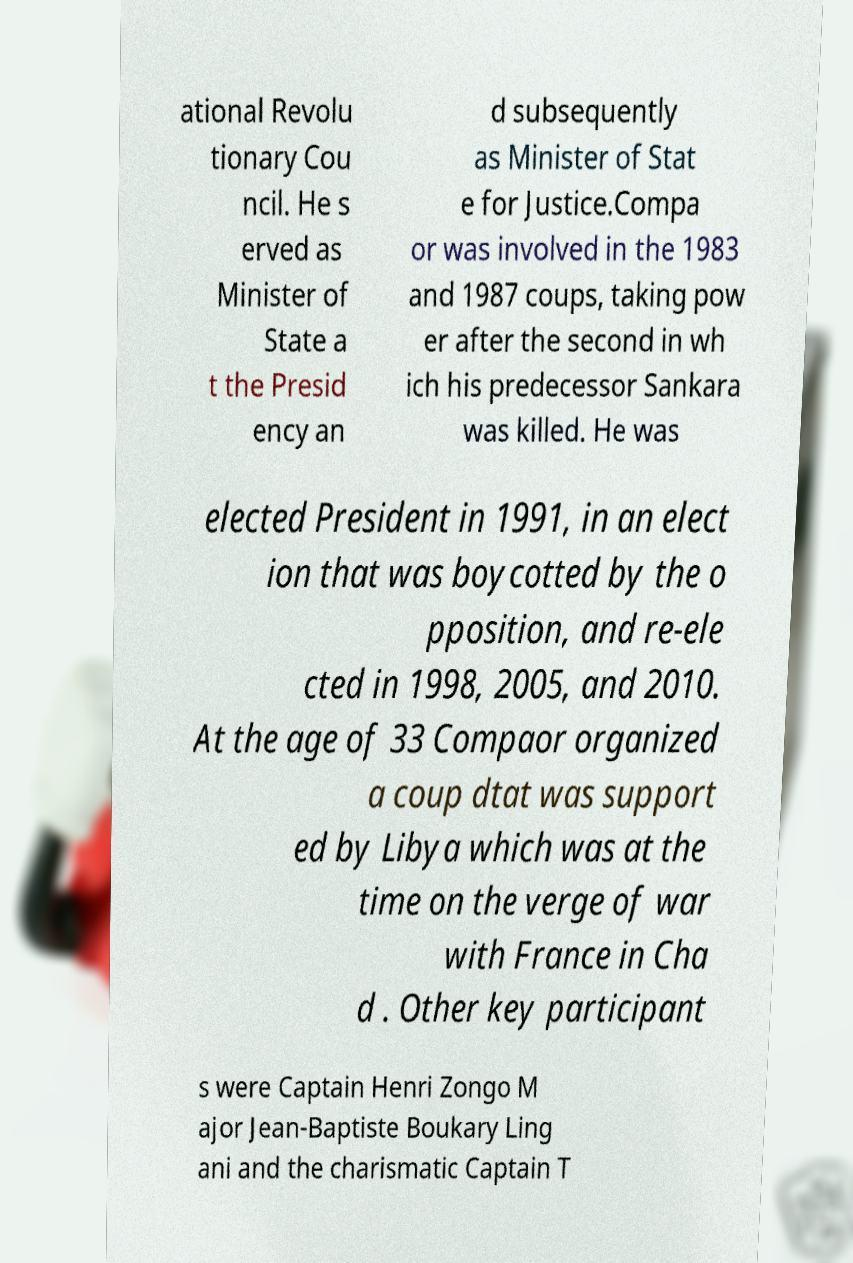What messages or text are displayed in this image? I need them in a readable, typed format. ational Revolu tionary Cou ncil. He s erved as Minister of State a t the Presid ency an d subsequently as Minister of Stat e for Justice.Compa or was involved in the 1983 and 1987 coups, taking pow er after the second in wh ich his predecessor Sankara was killed. He was elected President in 1991, in an elect ion that was boycotted by the o pposition, and re-ele cted in 1998, 2005, and 2010. At the age of 33 Compaor organized a coup dtat was support ed by Libya which was at the time on the verge of war with France in Cha d . Other key participant s were Captain Henri Zongo M ajor Jean-Baptiste Boukary Ling ani and the charismatic Captain T 